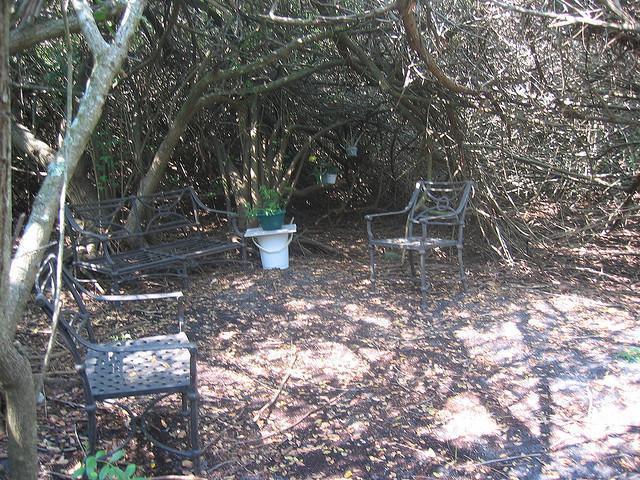What is near the flower pot?
Select the accurate answer and provide explanation: 'Answer: answer
Rationale: rationale.'
Options: Boat, chair, anteater, dog. Answer: chair.
Rationale: That's what's near the flower pot. 